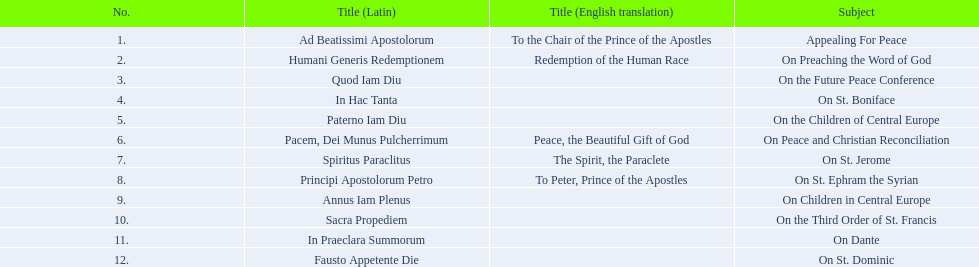What is the first english translation listed on the table? To the Chair of the Prince of the Apostles. 